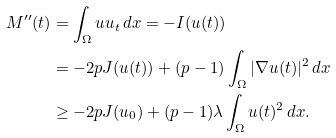Convert formula to latex. <formula><loc_0><loc_0><loc_500><loc_500>M ^ { \prime \prime } ( t ) & = \int _ { \Omega } u u _ { t } \, d x = - I ( u ( t ) ) \\ & = - 2 p J ( u ( t ) ) + ( p - 1 ) \int _ { \Omega } | \nabla u ( t ) | ^ { 2 } \, d x \\ & \geq - 2 p J ( u _ { 0 } ) + ( p - 1 ) \lambda \int _ { \Omega } u ( t ) ^ { 2 } \, d x .</formula> 